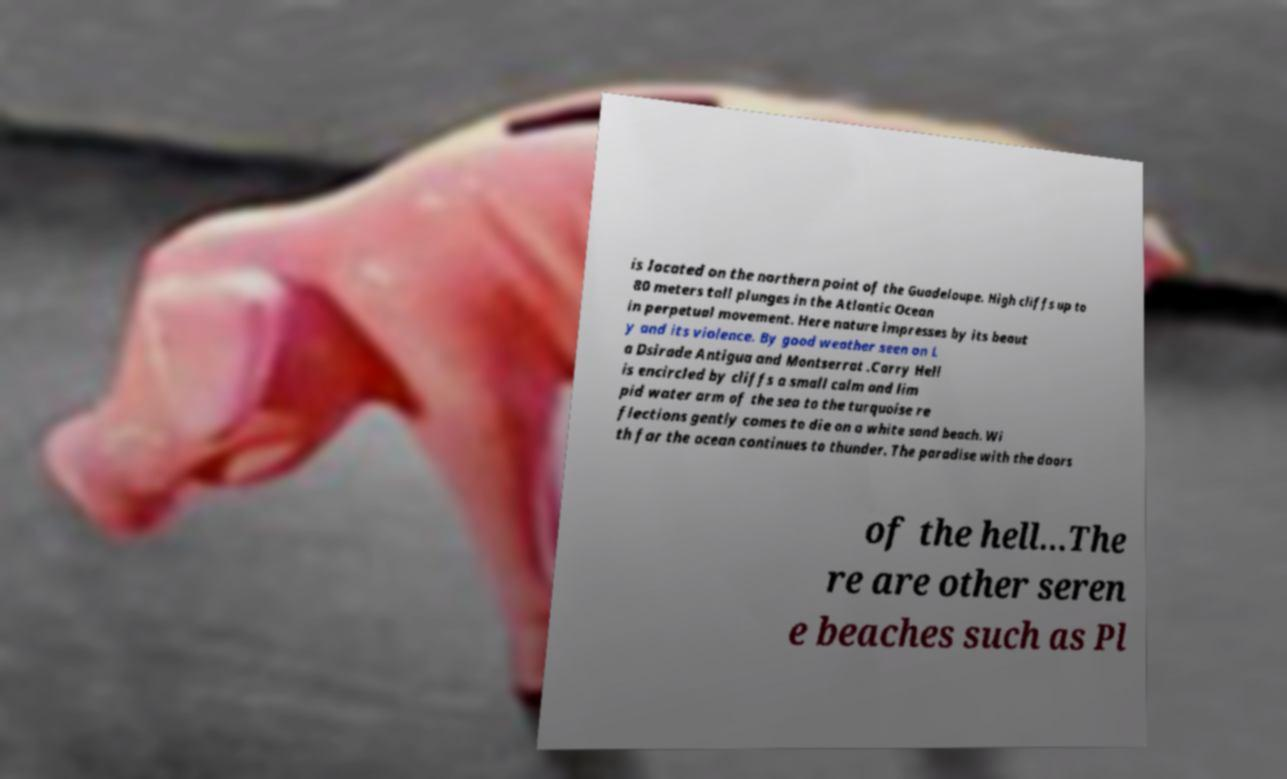Can you accurately transcribe the text from the provided image for me? is located on the northern point of the Guadeloupe. High cliffs up to 80 meters tall plunges in the Atlantic Ocean in perpetual movement. Here nature impresses by its beaut y and its violence. By good weather seen on L a Dsirade Antigua and Montserrat .Carry Hell is encircled by cliffs a small calm and lim pid water arm of the sea to the turquoise re flections gently comes to die on a white sand beach. Wi th far the ocean continues to thunder. The paradise with the doors of the hell…The re are other seren e beaches such as Pl 